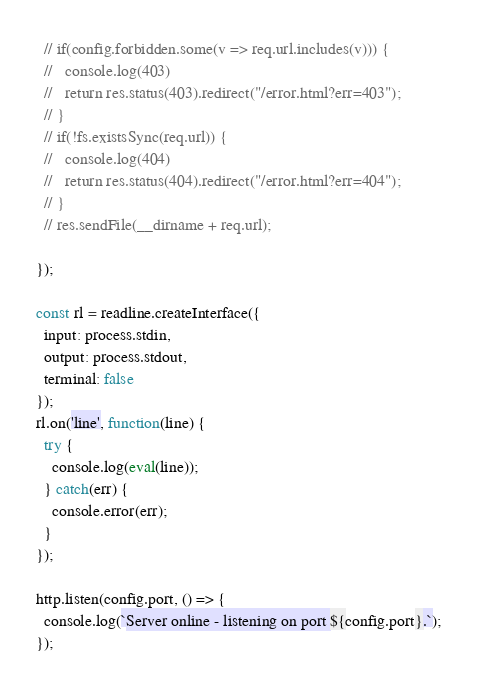Convert code to text. <code><loc_0><loc_0><loc_500><loc_500><_JavaScript_>  // if(config.forbidden.some(v => req.url.includes(v))) {
  //   console.log(403)
  //   return res.status(403).redirect("/error.html?err=403");
  // }
  // if(!fs.existsSync(req.url)) {
  //   console.log(404)
  //   return res.status(404).redirect("/error.html?err=404");
  // }
  // res.sendFile(__dirname + req.url);

});

const rl = readline.createInterface({
  input: process.stdin,
  output: process.stdout,
  terminal: false
});
rl.on('line', function(line) {
  try {
    console.log(eval(line));
  } catch(err) {
    console.error(err);
  }
});

http.listen(config.port, () => {
  console.log(`Server online - listening on port ${config.port}.`);
});
</code> 